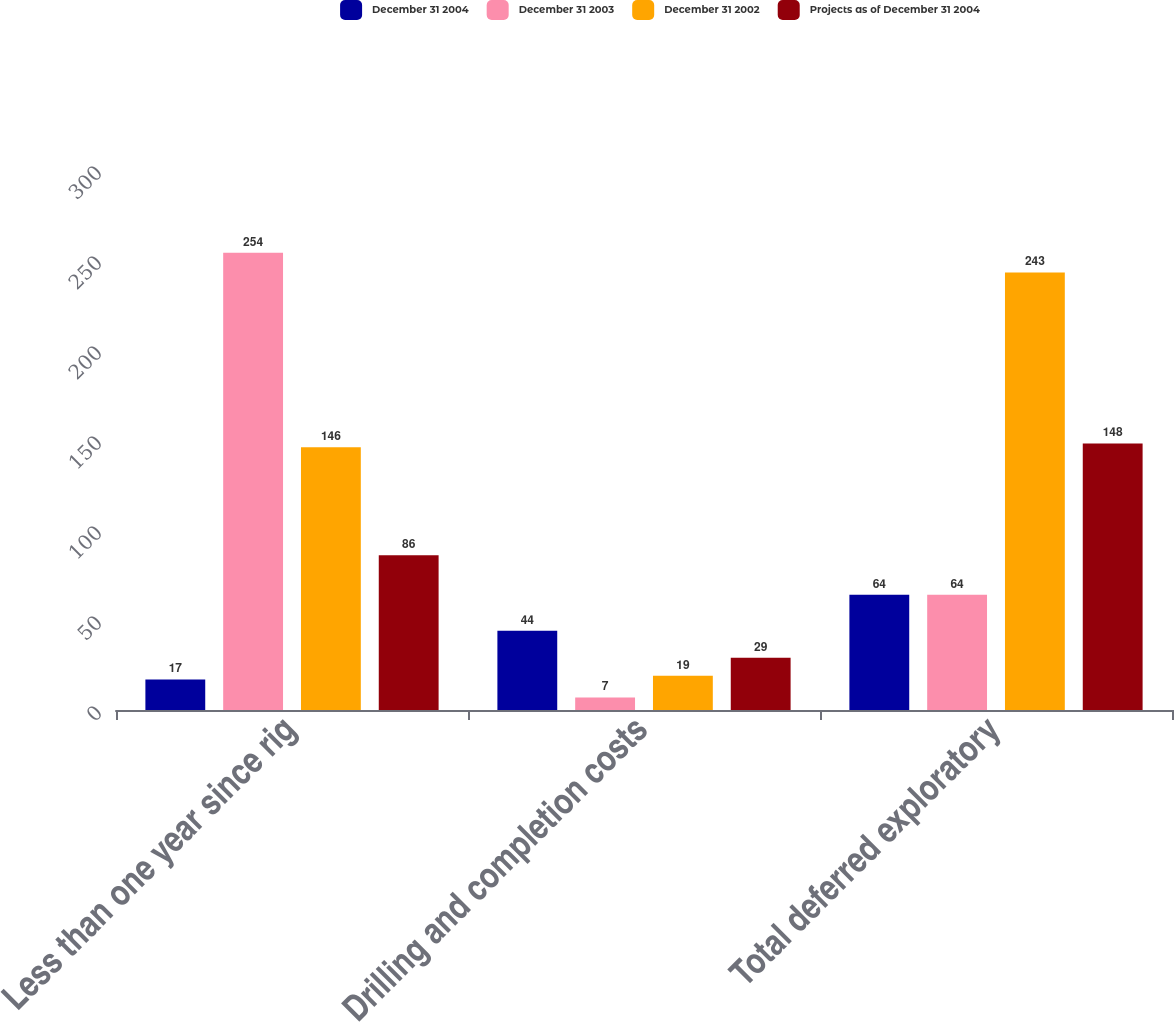Convert chart. <chart><loc_0><loc_0><loc_500><loc_500><stacked_bar_chart><ecel><fcel>Less than one year since rig<fcel>Drilling and completion costs<fcel>Total deferred exploratory<nl><fcel>December 31 2004<fcel>17<fcel>44<fcel>64<nl><fcel>December 31 2003<fcel>254<fcel>7<fcel>64<nl><fcel>December 31 2002<fcel>146<fcel>19<fcel>243<nl><fcel>Projects as of December 31 2004<fcel>86<fcel>29<fcel>148<nl></chart> 